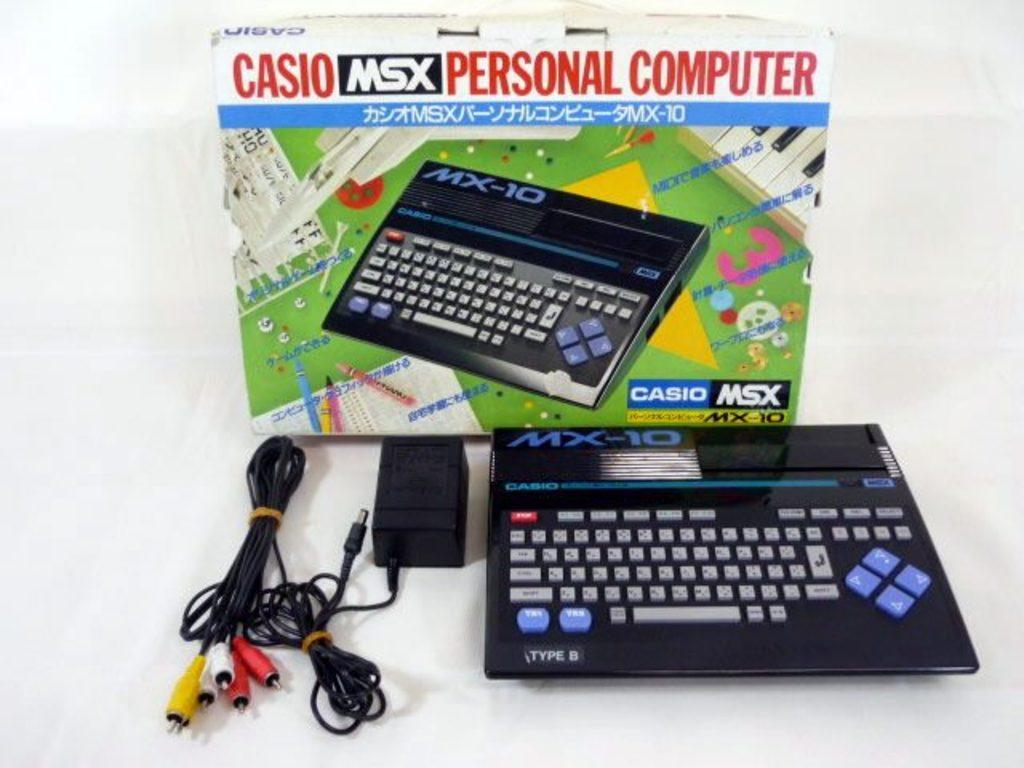<image>
Provide a brief description of the given image. a computer keyboard with MSX personal computer on the box 